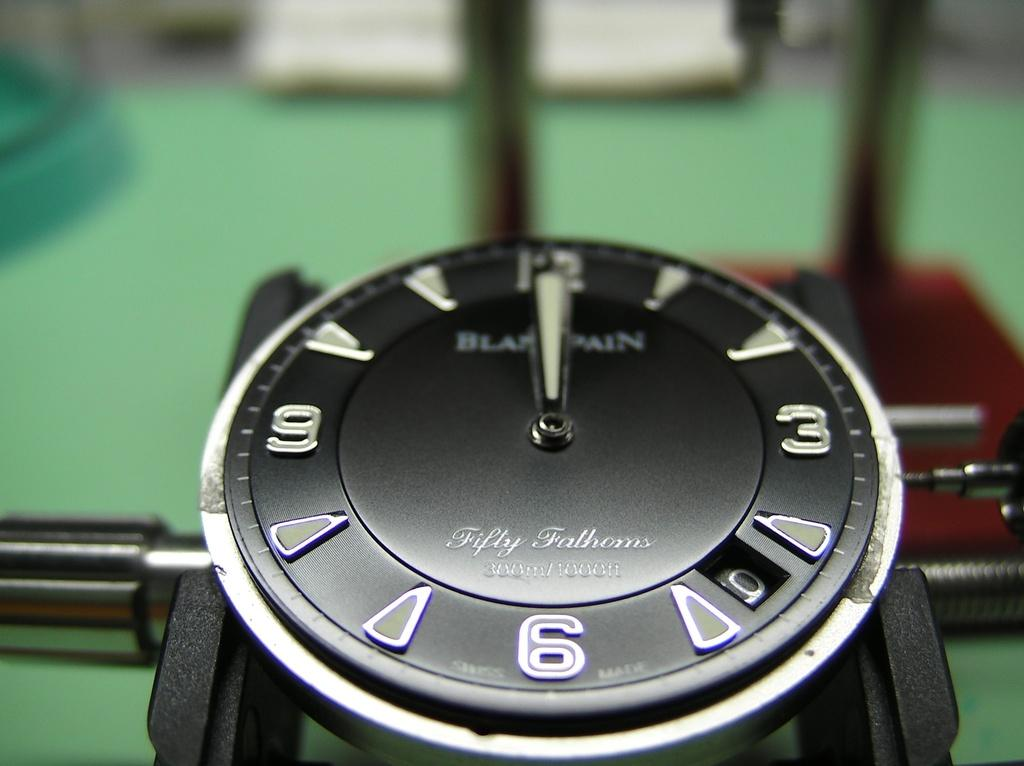<image>
Create a compact narrative representing the image presented. A Fifty Fathoms watch face is being shown in a closeup shot. 